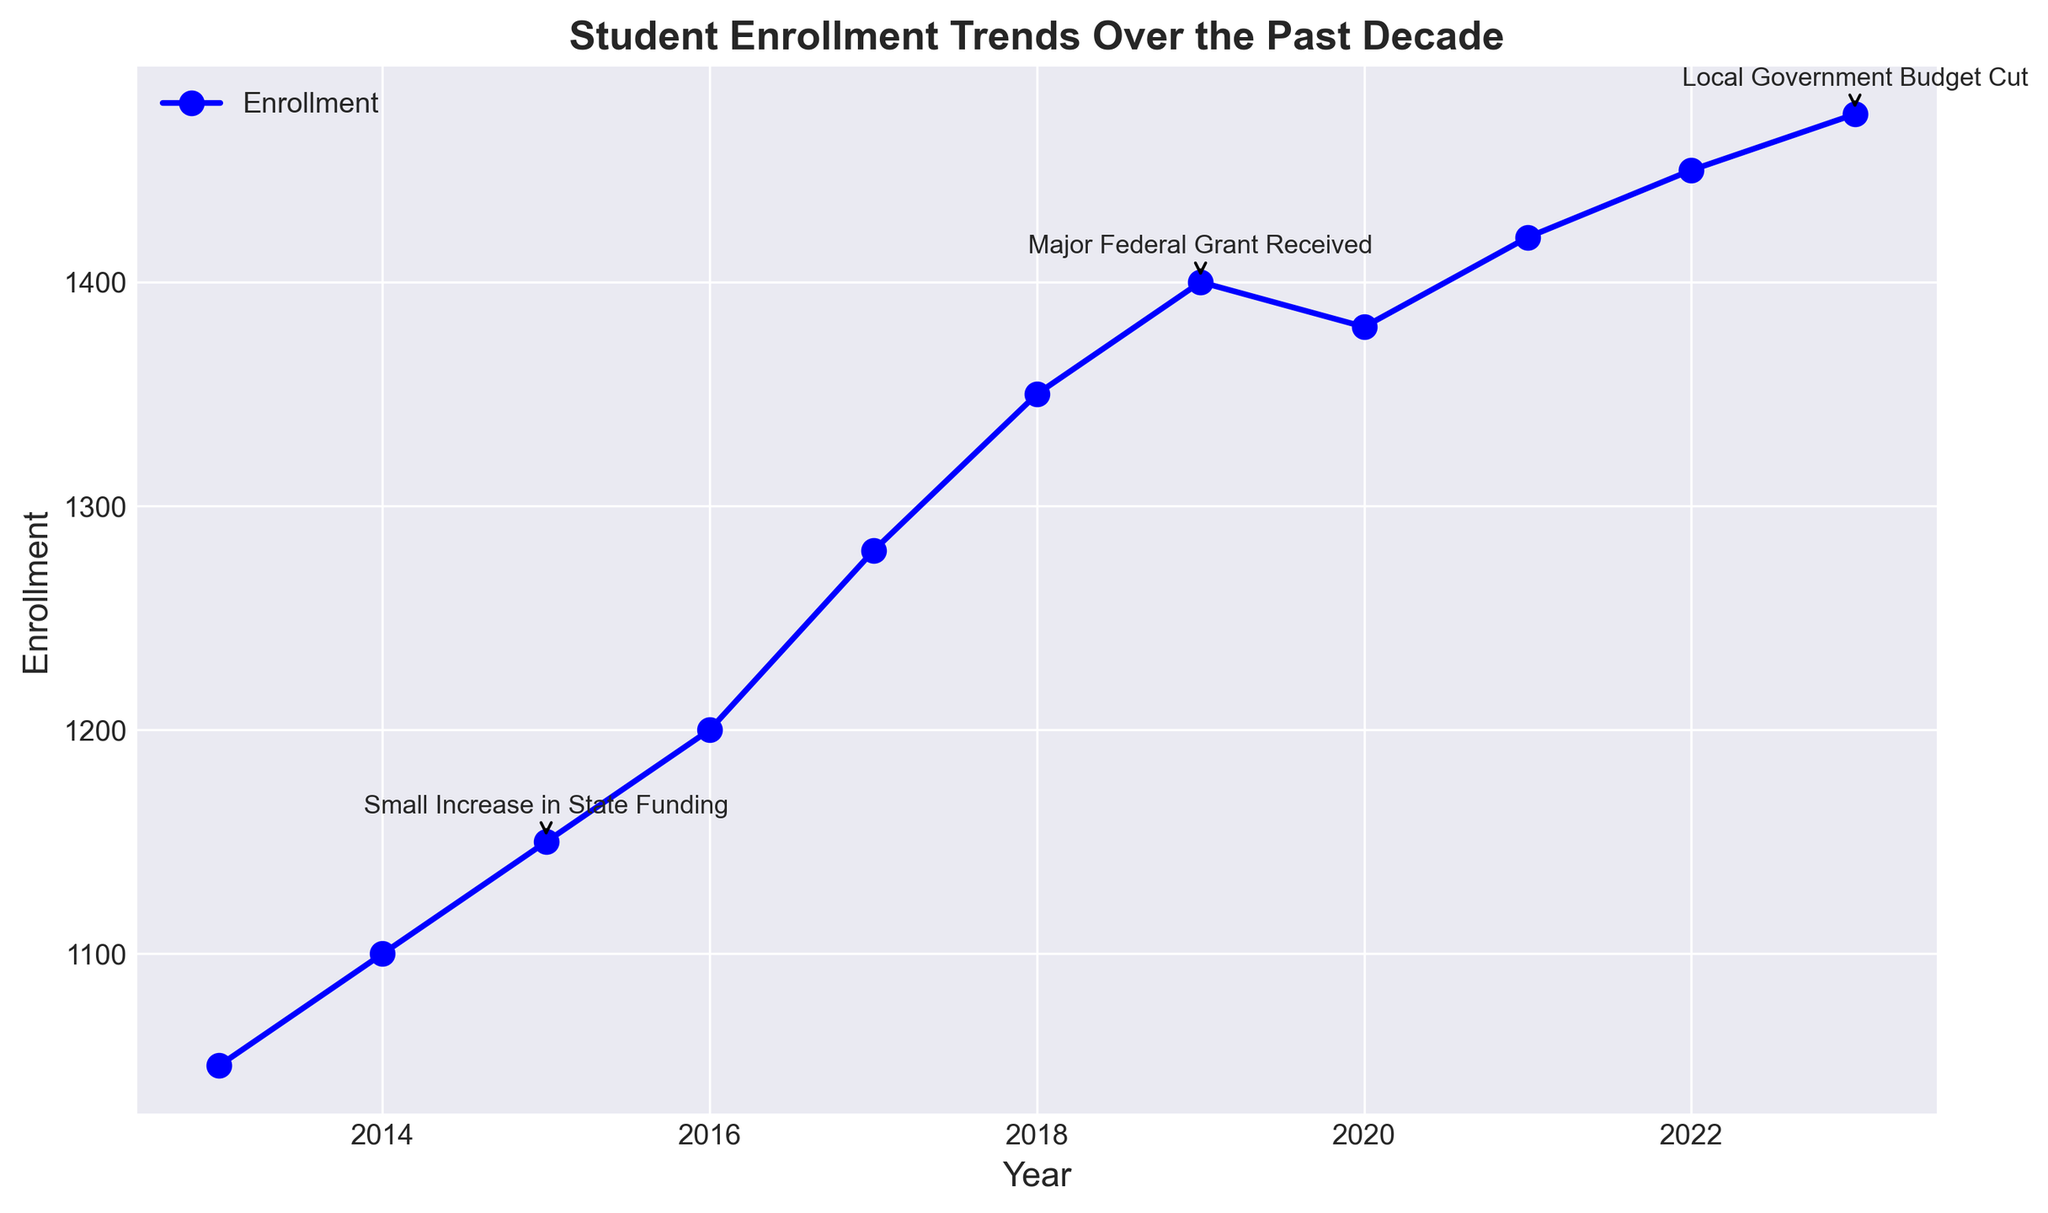What was the enrollment in 2019? Look at the data point for the year 2019 in the trend line. The enrollment is marked as 1400 students.
Answer: 1400 What was the enrollment increase from 2013 to 2023? Find the enrollment in 2013 (1050 students) and in 2023 (1475 students). The increase is calculated as 1475 - 1050 = 425 students.
Answer: 425 Which year had the highest increase in enrollment, and what was the enrollment difference between the two years? Compare the differences in enrollment year-by-year. The largest increase is between 2016 and 2017, where the difference is 1280 - 1200 = 80 students.
Answer: 2016 to 2017, 80 How did the major federal grant received in 2019 impact the enrollment trend immediately following it? Look at the enrollment in 2019 (1400 students) and compare it with the enrollment in 2020 (1380 students). There was a slight decrease of 20 students after receiving the grant.
Answer: Slight decrease, 20 students How did the enrollment change after the local government budget cut in 2023? Find the enrollment in 2023 (1475 students) and compare it with the previous year 2022 (1450 students). Despite the budget cut, enrollment increased by 25 students.
Answer: Increase, 25 students What is the compositional average enrollment across the entire decade? Sum the enrollments across all years and divide by the number of years: (1050 + 1100 + 1150 + 1200 + 1280 + 1350 + 1400 + 1380 + 1420 + 1450 + 1475) / 11 = 12413 / 11 ≈ 1128.45.
Answer: 1128.45 Which year had the smallest enrollment, and what was the value? Look at the plot and identify the year with the lowest data point for enrollment. In 2013, the enrollment was 1050, which is the smallest value.
Answer: 2013, 1050 Compare the enrollment trend before and after the small increase in state funding in 2015. Look at the trend from 2013 to 2015 and from 2015 to the subsequent years. Before 2015, the increase is gradual (1050 to 1150 in 2 years). After 2015, the trend remains positive but continues at a similar pace.
Answer: Gradual growth before and after What is the average enrollment between the years that have a funding milestone annotated? Combine the enrollment values for 2015, 2019, and 2023, then divide by the number of data points: (1150 + 1400 + 1475) / 3 = 4025 / 3 ≈ 1341.67.
Answer: 1341.67 What noticeable trend can you observe right after the funding milestone in 2019? Compare the enrollment data immediately before and after 2019. There is a slight dip in 2020 but generally, the enrollment continues to increase in subsequent years reaching 1475 in 2023.
Answer: Slight dip then growth 